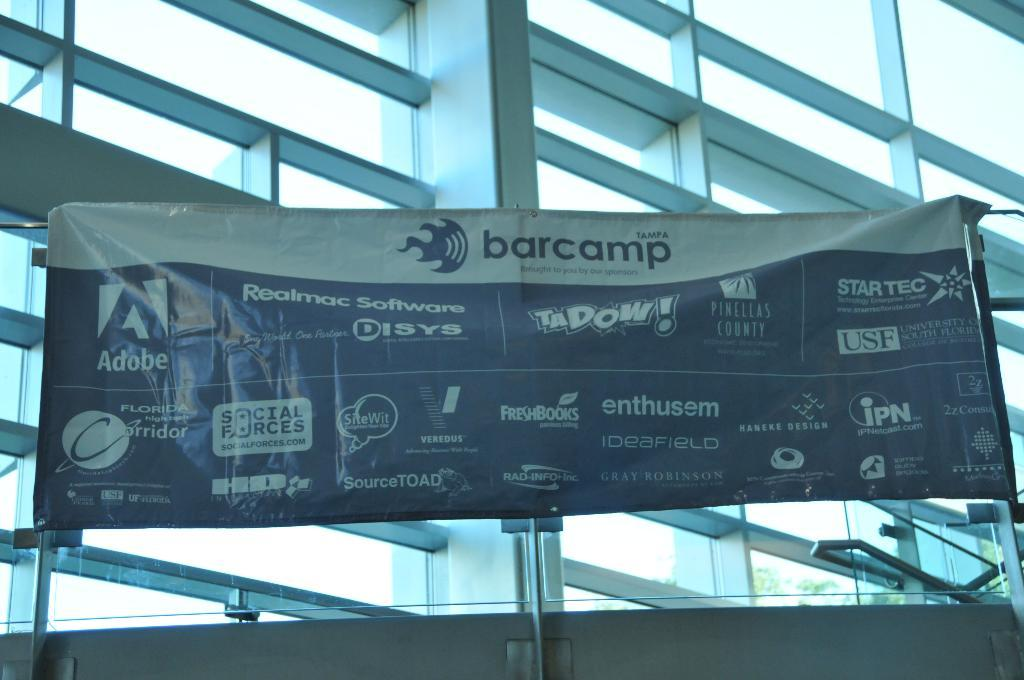What is located in the foreground of the image? There is a banner in the foreground of the image. How is the banner attached? The banner is attached to a glass railing. What can be seen in the background of the image? There is a glass wall in the background of the image. What is visible through the glass wall? The sky is visible through the glass wall. What type of board is being used to support the sidewalk in the image? There is no sidewalk or board present in the image; it features a banner attached to a glass railing and a glass wall with the sky visible through it. 